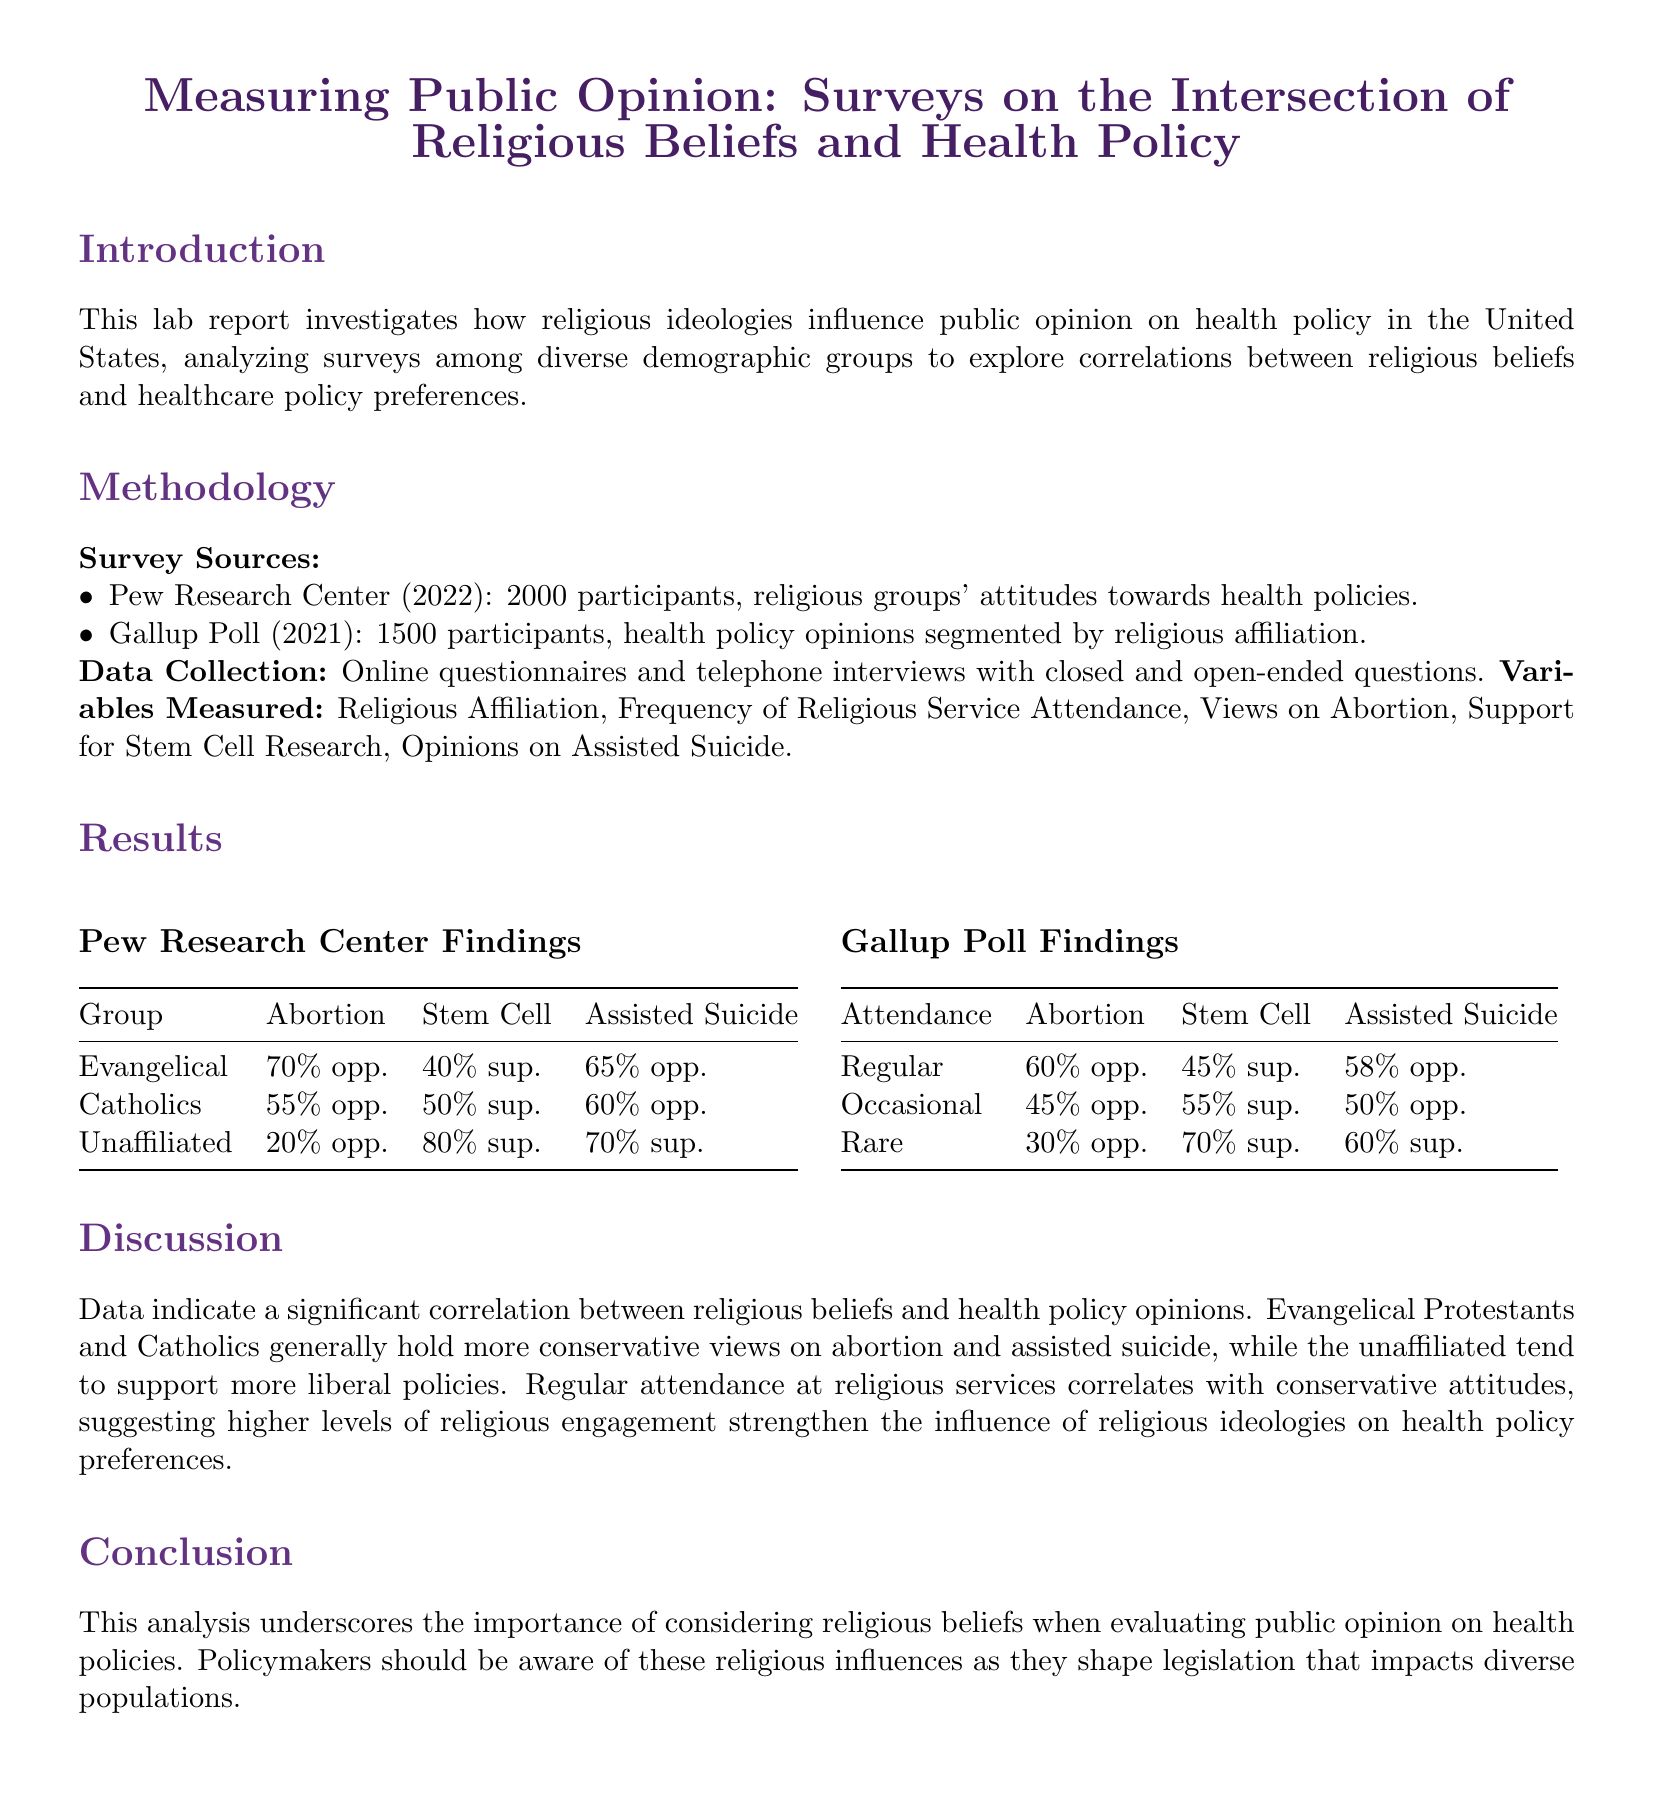What is the title of the lab report? The title is given at the beginning of the document, summarizing the content focus.
Answer: Measuring Public Opinion: Surveys on the Intersection of Religious Beliefs and Health Policy How many participants were surveyed by Pew Research Center? The Pew Research Center section lists the number of participants clearly.
Answer: 2000 What percentage of Evangelicals oppose abortion? The findings table from Pew Research Center provides this specific percentage.
Answer: 70% Which group showed the highest support for stem cell research according to the Pew Research Center? The results table clearly indicates which group supports stem cell research the most.
Answer: Unaffiliated What trend is observed in relation to religious service attendance and health policy opinions? The discussion section summarizes the relationship between attendance and attitudes.
Answer: Correlation What methodology was used for data collection in the study? The methodology section describes the methods for gathering data in detail.
Answer: Online questionnaires and telephone interviews Which health policy opinion is supported by 80% of the UnaBilliated? The Pew Research Center results outline opinions on specific policies for different groups.
Answer: Stem Cell What is one implication of this study for policymakers? The conclusion summarizes the relevance of the findings for those in power.
Answer: Consideration of religious beliefs 